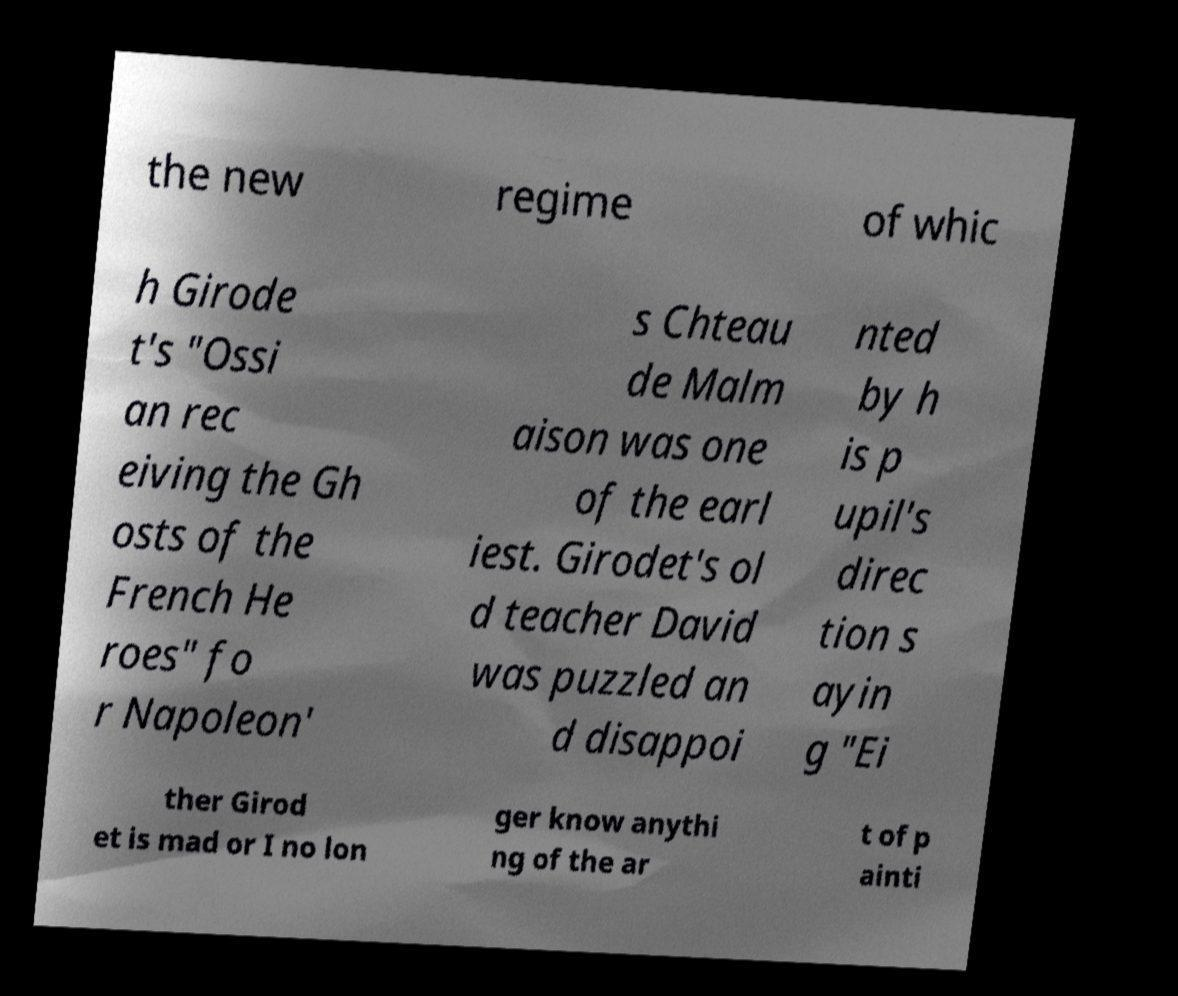Can you read and provide the text displayed in the image?This photo seems to have some interesting text. Can you extract and type it out for me? the new regime of whic h Girode t's "Ossi an rec eiving the Gh osts of the French He roes" fo r Napoleon' s Chteau de Malm aison was one of the earl iest. Girodet's ol d teacher David was puzzled an d disappoi nted by h is p upil's direc tion s ayin g "Ei ther Girod et is mad or I no lon ger know anythi ng of the ar t of p ainti 